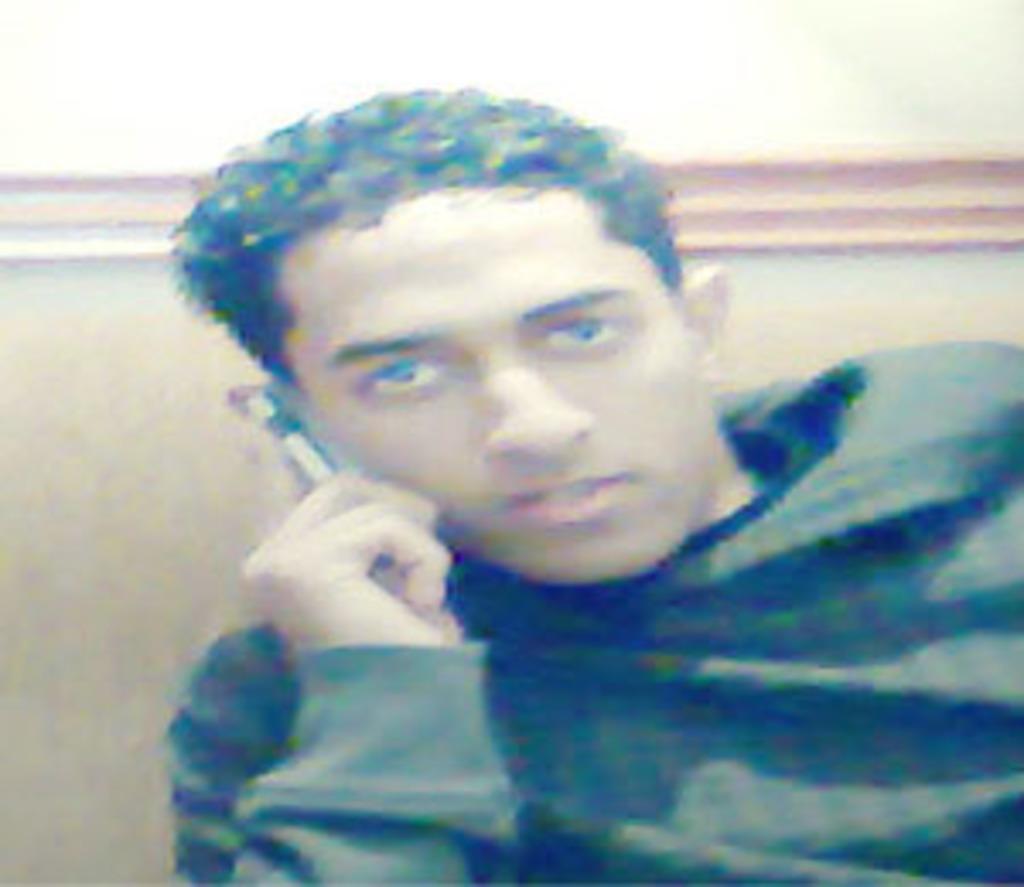Can you describe this image briefly? This image consists of a man wearing black T-shirt is talking on the phone. In the background, there is a wall. 